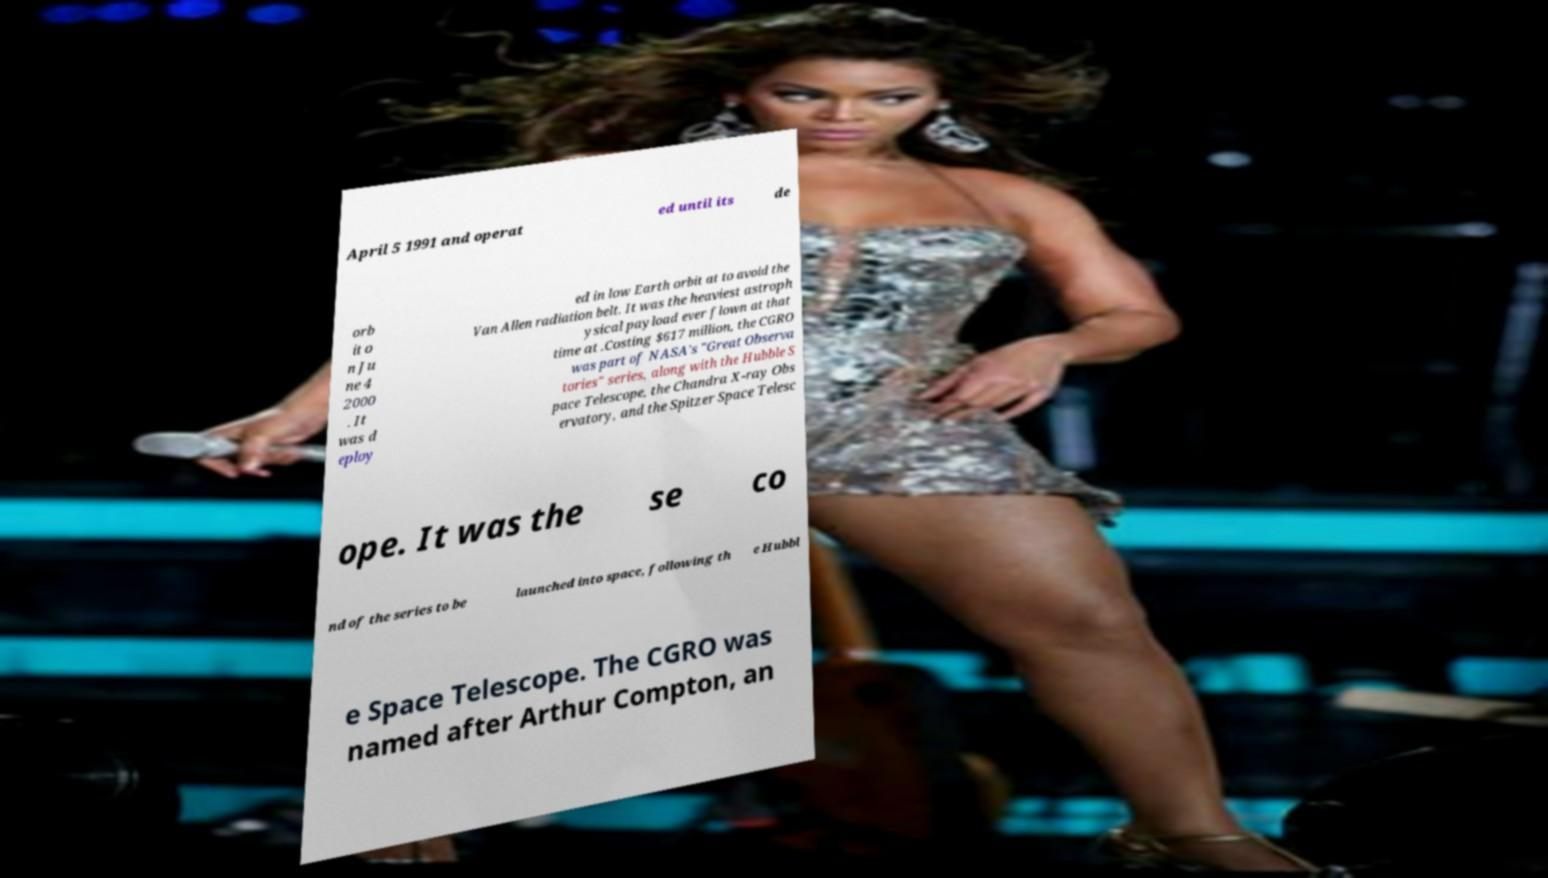Could you assist in decoding the text presented in this image and type it out clearly? April 5 1991 and operat ed until its de orb it o n Ju ne 4 2000 . It was d eploy ed in low Earth orbit at to avoid the Van Allen radiation belt. It was the heaviest astroph ysical payload ever flown at that time at .Costing $617 million, the CGRO was part of NASA's "Great Observa tories" series, along with the Hubble S pace Telescope, the Chandra X-ray Obs ervatory, and the Spitzer Space Telesc ope. It was the se co nd of the series to be launched into space, following th e Hubbl e Space Telescope. The CGRO was named after Arthur Compton, an 